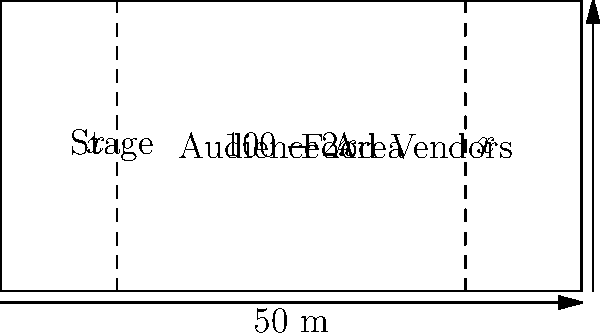A nostalgic Toronto-based music festival is being planned in Vancouver. The organizers have secured a rectangular space that is 100 meters wide and 50 meters deep. They want to allocate equal space on both sides for a stage and food vendors, with the remaining central area for the audience. If $x$ represents the width of both the stage and food vendor areas, express the audience area $A$ as a function of $x$. Then, determine the value of $x$ that maximizes the audience area and calculate the maximum area. Let's approach this step-by-step:

1) The total width is 100 m, and we're allocating $x$ meters for both the stage and food vendor areas. So, the audience area width is $100 - 2x$ meters.

2) The depth of the entire area is 50 m, which is also the depth of the audience area.

3) Therefore, the audience area $A$ as a function of $x$ is:

   $A(x) = (100 - 2x) \cdot 50 = 5000 - 100x$ square meters

4) To maximize this area, we need to find the value of $x$ where $\frac{dA}{dx} = 0$:

   $\frac{dA}{dx} = -100$

5) Setting this equal to zero:

   $-100 = 0$

6) This is always true, meaning there is no maximum or minimum within the domain. The function is linear, so the maximum will occur at one of the endpoints of the domain.

7) The domain of $x$ is $[0, 50]$, as $x$ cannot be negative and cannot exceed half the total width.

8) Let's evaluate $A(x)$ at these endpoints:

   $A(0) = 5000 - 100(0) = 5000$ sq m
   $A(50) = 5000 - 100(50) = 0$ sq m

9) Clearly, the maximum occurs when $x = 0$, meaning no space is allocated for the stage or food vendors.

10) However, as this is impractical, the organizers would need to choose a small, non-zero value for $x$ based on their specific needs.
Answer: Maximum audience area: 5000 sq m when $x = 0$ m 